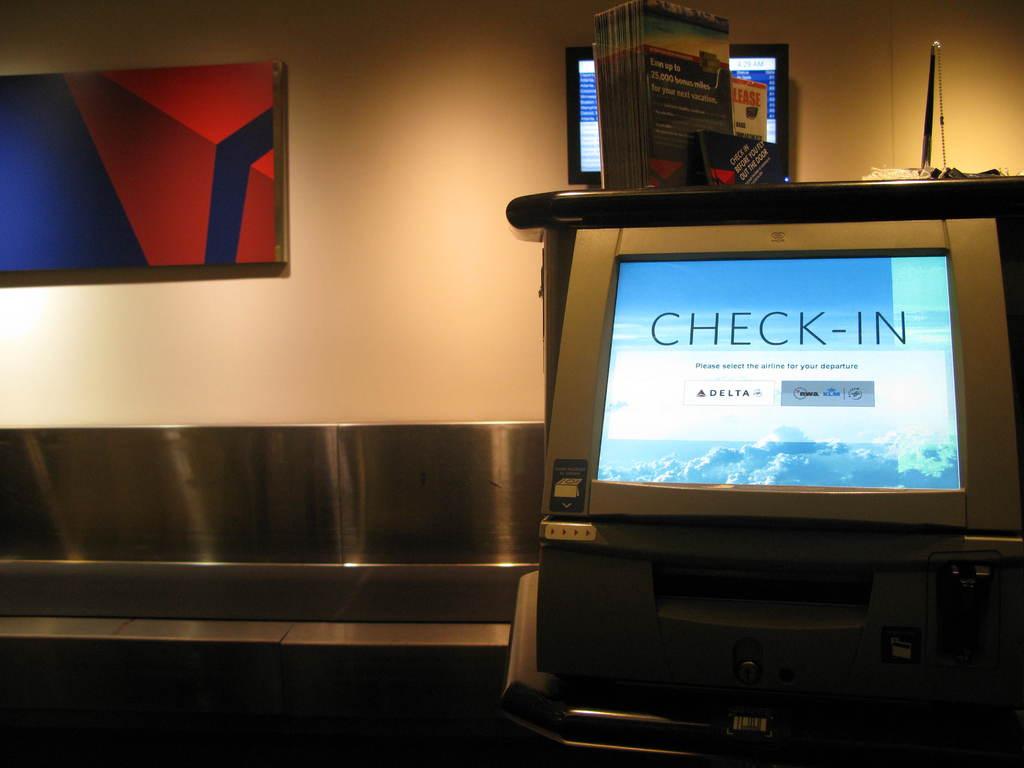What are you checking in for?
Your answer should be very brief. Delta. What is the airline?
Give a very brief answer. Delta. 